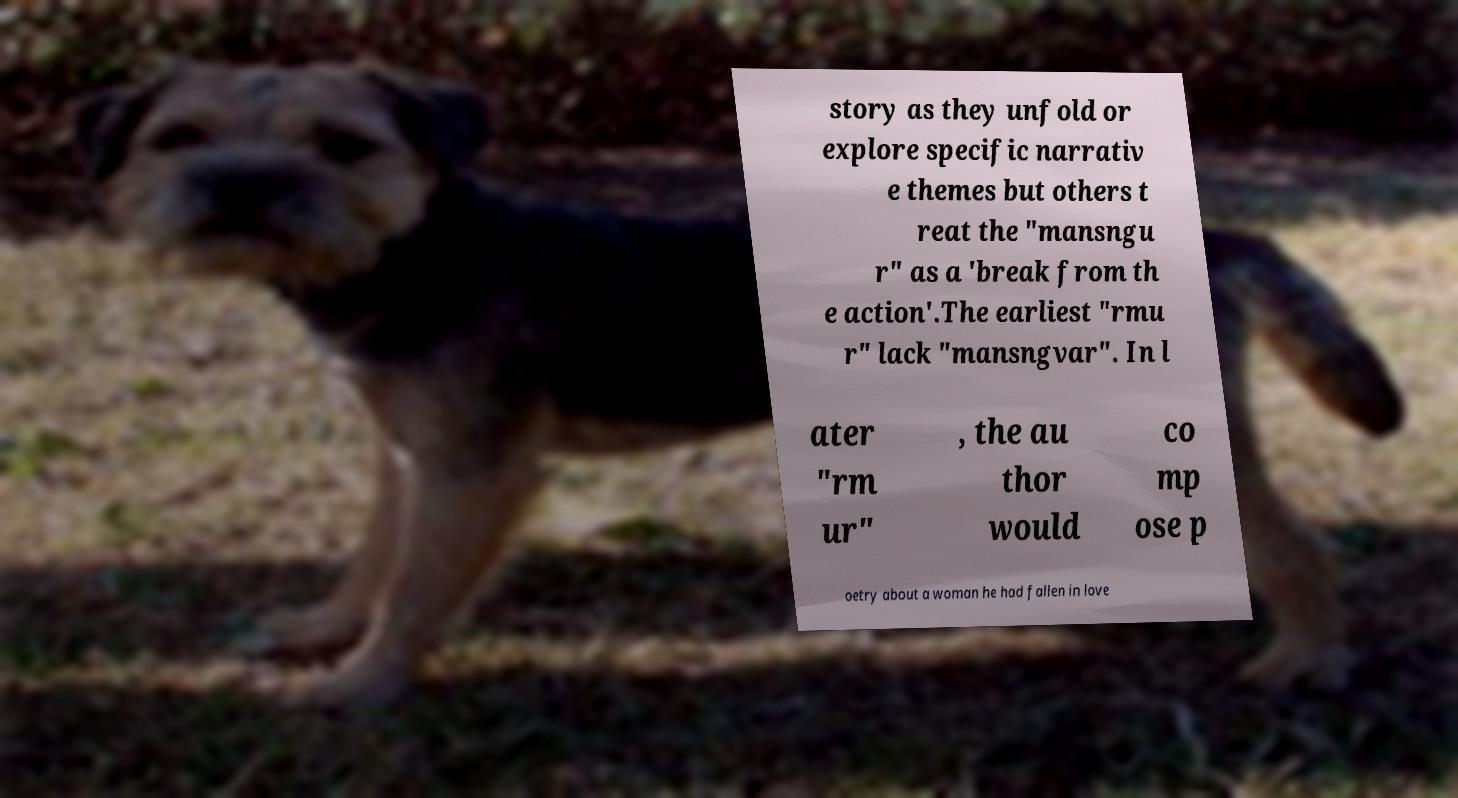I need the written content from this picture converted into text. Can you do that? story as they unfold or explore specific narrativ e themes but others t reat the "mansngu r" as a 'break from th e action'.The earliest "rmu r" lack "mansngvar". In l ater "rm ur" , the au thor would co mp ose p oetry about a woman he had fallen in love 